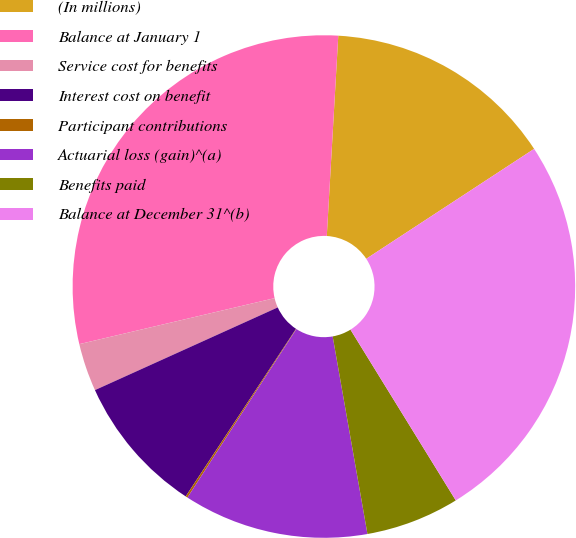<chart> <loc_0><loc_0><loc_500><loc_500><pie_chart><fcel>(In millions)<fcel>Balance at January 1<fcel>Service cost for benefits<fcel>Interest cost on benefit<fcel>Participant contributions<fcel>Actuarial loss (gain)^(a)<fcel>Benefits paid<fcel>Balance at December 31^(b)<nl><fcel>14.86%<fcel>29.59%<fcel>3.08%<fcel>8.97%<fcel>0.13%<fcel>11.91%<fcel>6.02%<fcel>25.43%<nl></chart> 